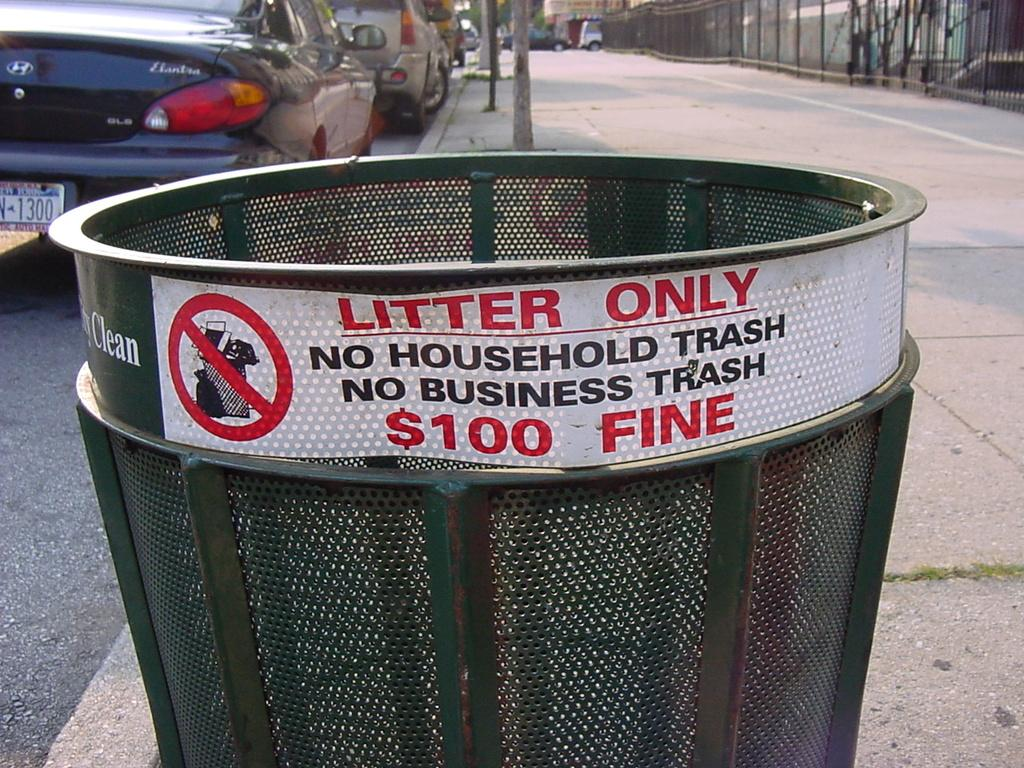<image>
Give a short and clear explanation of the subsequent image. A trash can warns of a one hundred dollar fine for putting household trash in it. 